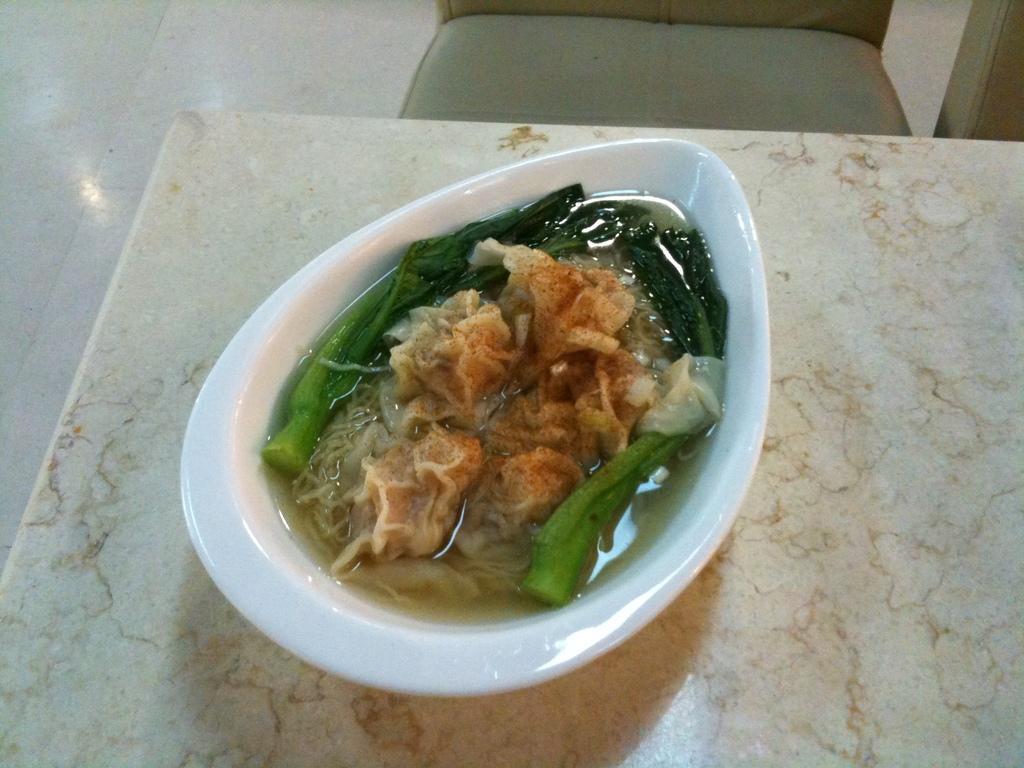Could you give a brief overview of what you see in this image? In the picture we can see some food item which is in white color bowl which is placed on the surface of a table. 